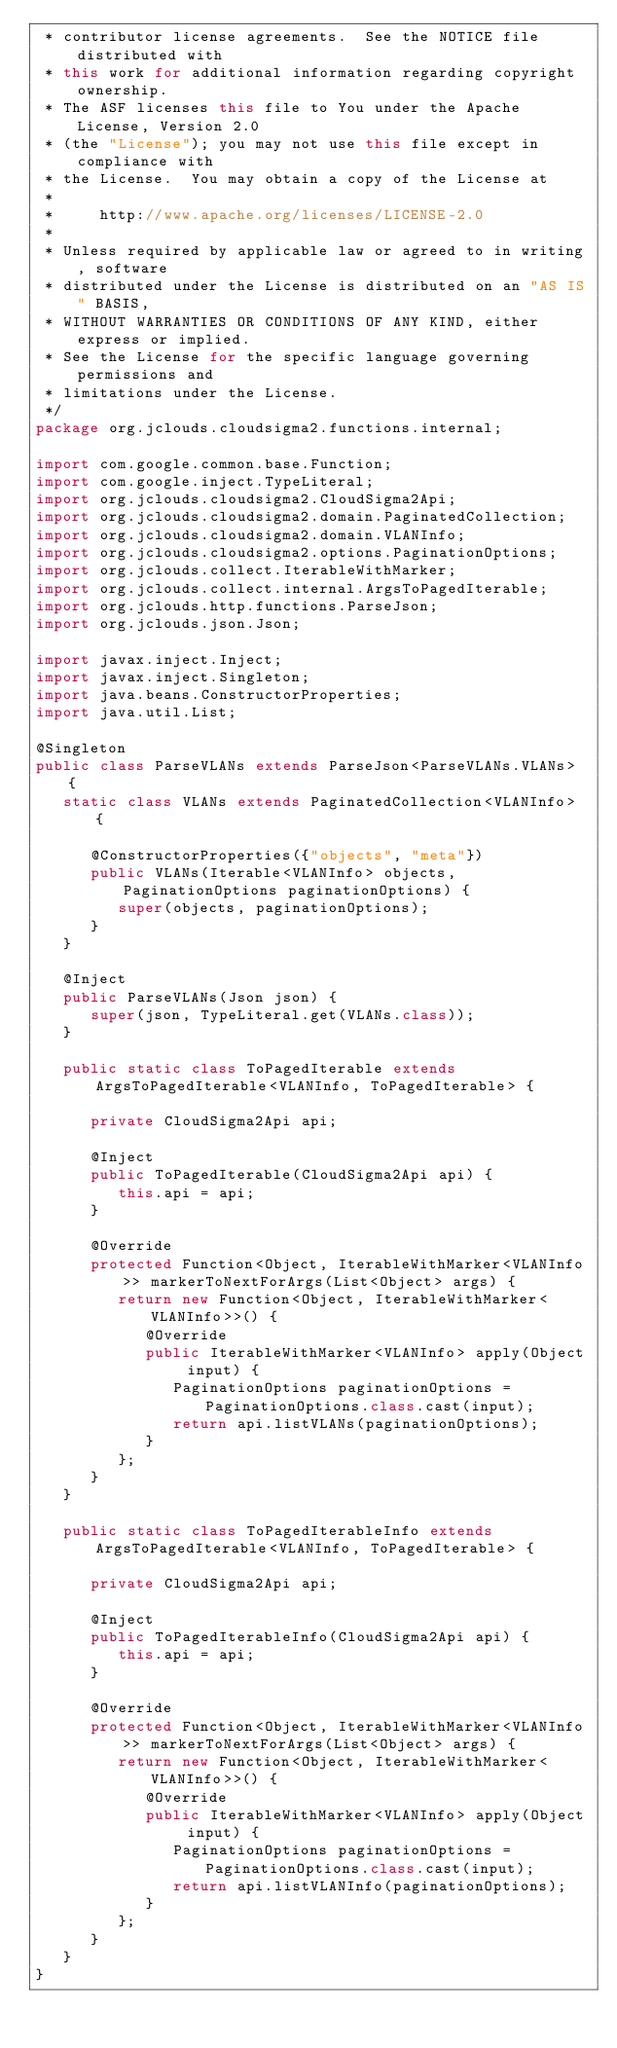Convert code to text. <code><loc_0><loc_0><loc_500><loc_500><_Java_> * contributor license agreements.  See the NOTICE file distributed with
 * this work for additional information regarding copyright ownership.
 * The ASF licenses this file to You under the Apache License, Version 2.0
 * (the "License"); you may not use this file except in compliance with
 * the License.  You may obtain a copy of the License at
 *
 *     http://www.apache.org/licenses/LICENSE-2.0
 *
 * Unless required by applicable law or agreed to in writing, software
 * distributed under the License is distributed on an "AS IS" BASIS,
 * WITHOUT WARRANTIES OR CONDITIONS OF ANY KIND, either express or implied.
 * See the License for the specific language governing permissions and
 * limitations under the License.
 */
package org.jclouds.cloudsigma2.functions.internal;

import com.google.common.base.Function;
import com.google.inject.TypeLiteral;
import org.jclouds.cloudsigma2.CloudSigma2Api;
import org.jclouds.cloudsigma2.domain.PaginatedCollection;
import org.jclouds.cloudsigma2.domain.VLANInfo;
import org.jclouds.cloudsigma2.options.PaginationOptions;
import org.jclouds.collect.IterableWithMarker;
import org.jclouds.collect.internal.ArgsToPagedIterable;
import org.jclouds.http.functions.ParseJson;
import org.jclouds.json.Json;

import javax.inject.Inject;
import javax.inject.Singleton;
import java.beans.ConstructorProperties;
import java.util.List;

@Singleton
public class ParseVLANs extends ParseJson<ParseVLANs.VLANs> {
   static class VLANs extends PaginatedCollection<VLANInfo> {

      @ConstructorProperties({"objects", "meta"})
      public VLANs(Iterable<VLANInfo> objects, PaginationOptions paginationOptions) {
         super(objects, paginationOptions);
      }
   }

   @Inject
   public ParseVLANs(Json json) {
      super(json, TypeLiteral.get(VLANs.class));
   }

   public static class ToPagedIterable extends ArgsToPagedIterable<VLANInfo, ToPagedIterable> {

      private CloudSigma2Api api;

      @Inject
      public ToPagedIterable(CloudSigma2Api api) {
         this.api = api;
      }

      @Override
      protected Function<Object, IterableWithMarker<VLANInfo>> markerToNextForArgs(List<Object> args) {
         return new Function<Object, IterableWithMarker<VLANInfo>>() {
            @Override
            public IterableWithMarker<VLANInfo> apply(Object input) {
               PaginationOptions paginationOptions = PaginationOptions.class.cast(input);
               return api.listVLANs(paginationOptions);
            }
         };
      }
   }

   public static class ToPagedIterableInfo extends ArgsToPagedIterable<VLANInfo, ToPagedIterable> {

      private CloudSigma2Api api;

      @Inject
      public ToPagedIterableInfo(CloudSigma2Api api) {
         this.api = api;
      }

      @Override
      protected Function<Object, IterableWithMarker<VLANInfo>> markerToNextForArgs(List<Object> args) {
         return new Function<Object, IterableWithMarker<VLANInfo>>() {
            @Override
            public IterableWithMarker<VLANInfo> apply(Object input) {
               PaginationOptions paginationOptions = PaginationOptions.class.cast(input);
               return api.listVLANInfo(paginationOptions);
            }
         };
      }
   }
}
</code> 